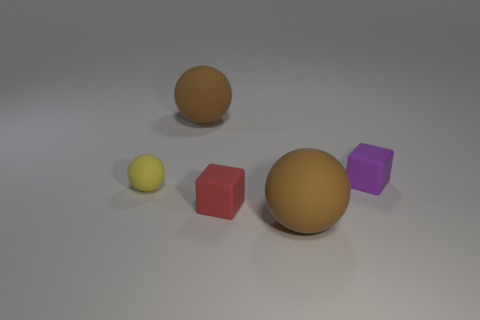Is there a small blue thing made of the same material as the red cube?
Provide a succinct answer. No. What shape is the yellow rubber thing?
Keep it short and to the point. Sphere. What is the color of the tiny sphere that is made of the same material as the tiny purple block?
Provide a short and direct response. Yellow. How many brown objects are tiny matte objects or large rubber spheres?
Ensure brevity in your answer.  2. Are there more small shiny cylinders than blocks?
Provide a succinct answer. No. How many objects are large brown matte objects that are in front of the small sphere or purple rubber blocks that are to the right of the red rubber thing?
Ensure brevity in your answer.  2. What color is the other matte cube that is the same size as the purple cube?
Your answer should be compact. Red. Are there more brown matte spheres that are behind the small rubber sphere than tiny brown matte things?
Offer a very short reply. Yes. What number of other things are the same size as the yellow object?
Provide a short and direct response. 2. The matte object that is to the right of the big rubber sphere in front of the large thing that is behind the tiny yellow thing is what color?
Your answer should be very brief. Purple. 